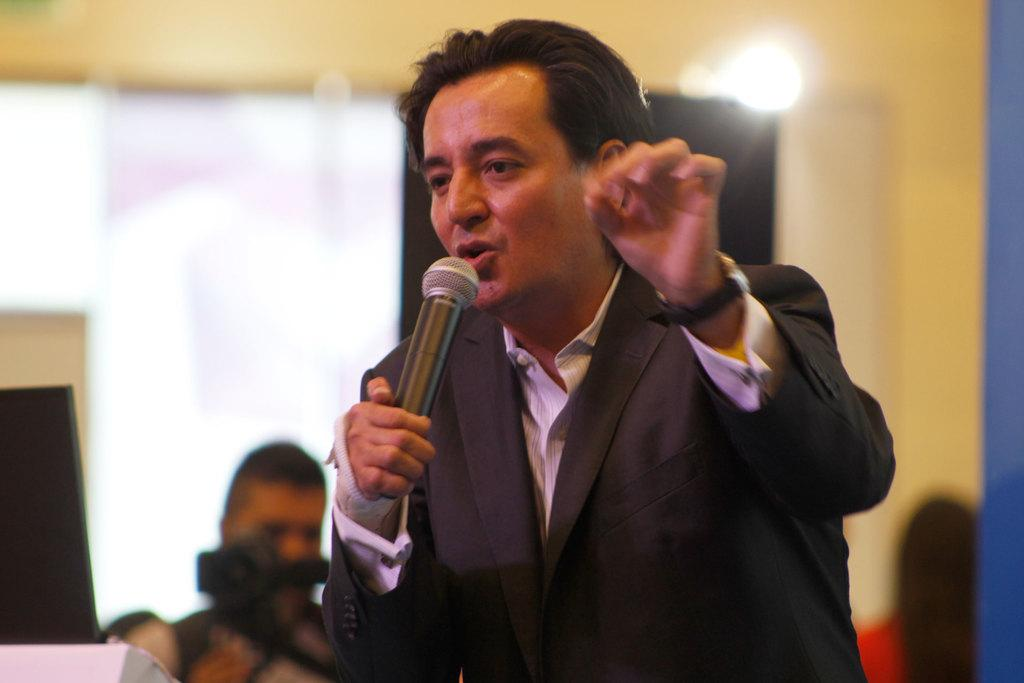Who is the main subject in the image? There is a man in the image. What is the man wearing? The man is wearing a suit. What is the man doing in the image? The man is speaking in front of a microphone. What can be seen above the man in the image? There is a light above the man. What is the person holding in the image? A person is holding a camera in the image. What type of bird can be seen flying in the image? There is no bird present in the image. What color is the pencil that the man is using to write his speech? The man is speaking in front of a microphone, not writing with a pencil, so there is no pencil present in the image. 